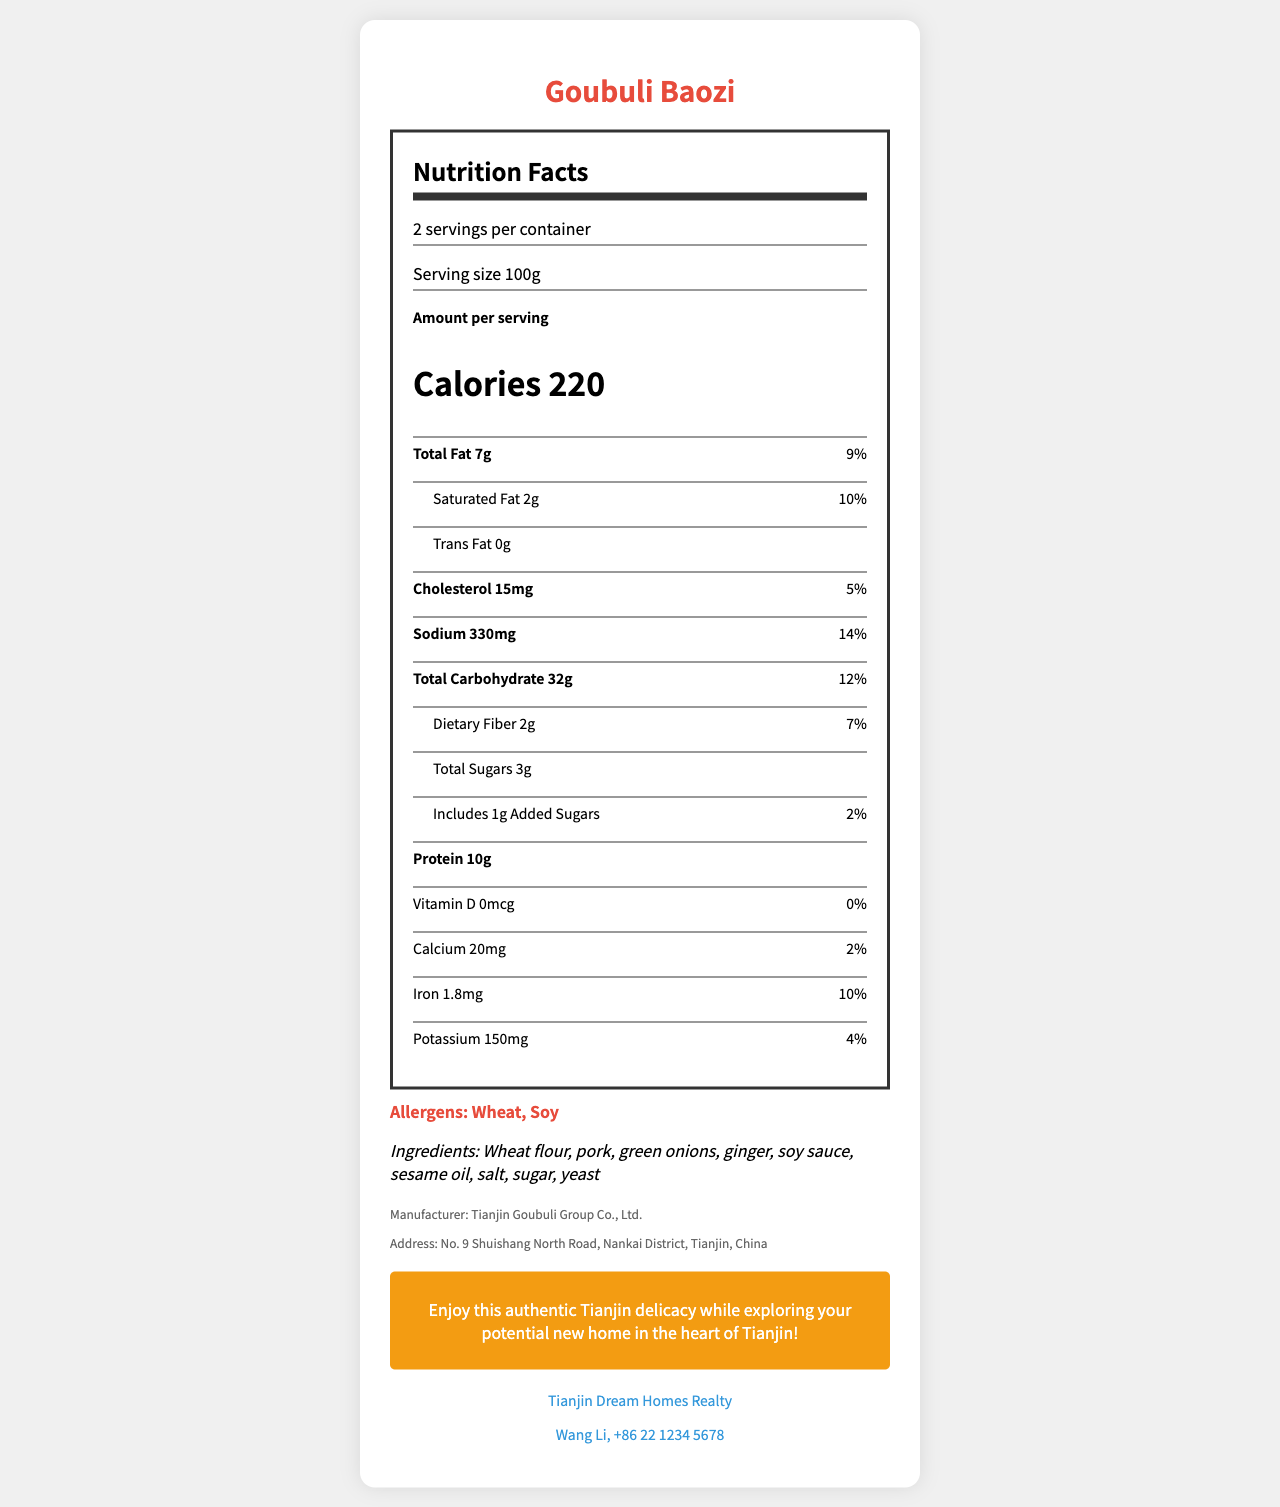how many servings are in the container? According to the document, there are 2 servings per container.
Answer: 2 what is the serving size of Goubuli Baozi? The serving size of Goubuli Baozi is listed as 100g in the document.
Answer: 100g how many calories are in one serving of Goubuli Baozi? The document states that one serving of Goubuli Baozi contains 220 calories.
Answer: 220 how many total fats are in one serving, and what percentage of the daily value does this represent? One serving of Goubuli Baozi contains 7g of total fat, which is 9% of the daily value.
Answer: 7g, 9% what allergens are present in Goubuli Baozi? The document lists the allergens present in Goubuli Baozi as Wheat and Soy.
Answer: Wheat, Soy which nutrient has a daily value of 14%? A. Cholesterol B. Sodium C. Calcium The document shows that Sodium has a daily value of 14%.
Answer: B how much protein is contained in one serving of Goubuli Baozi? A. 7g B. 10g C. 15g One serving of Goubuli Baozi contains 10g of protein.
Answer: B how much iron does Goubuli Baozi provide per serving, and what is its daily value percentage? Each serving of Goubuli Baozi provides 1.8mg of iron, which is 10% of the daily value.
Answer: 1.8mg, 10% does Goubuli Baozi contain any added sugars? The document indicates that Goubuli Baozi contains 1g of added sugars.
Answer: Yes does the document mention if Goubuli Baozi is gluten-free? The document does not mention whether Goubuli Baozi is gluten-free.
Answer: No summarize the main information provided in this document. This summary includes the essential nutritional information about Goubuli Baozi and context about its use in the open house event.
Answer: The document presents the nutritional facts for Goubuli Baozi, a traditional Tianjin snack. It details serving size, servings per container, calorie content, and the amounts and daily values for several nutrients. It also notes allergens, ingredients, manufacturer information, an open house note, and contact information for the real estate agency. what is the manufacturer's address for Goubuli Baozi? The manufacturer's address listed in the document is No. 9 Shuishang North Road, Nankai District, Tianjin, China.
Answer: No. 9 Shuishang North Road, Nankai District, Tianjin, China who can you contact for more information about the real estate event? The document provides the contact information for the real estate agent, Wang Li, at +86 22 1234 5678.
Answer: Wang Li, +86 22 1234 5678 how many grams of dietary fiber are in one serving of Goubuli Baozi? One serving of Goubuli Baozi contains 2g of dietary fiber.
Answer: 2g which nutrient listed has a daily value percentage of 0%? The document shows that Vitamin D has a daily value of 0%.
Answer: Vitamin D what flavor is the Goubuli Baozi? The document does not specify the flavor of Goubuli Baozi.
Answer: Not enough information 